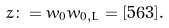Convert formula to latex. <formula><loc_0><loc_0><loc_500><loc_500>z \colon = w _ { 0 } w _ { 0 , L } = [ 5 6 3 ] .</formula> 